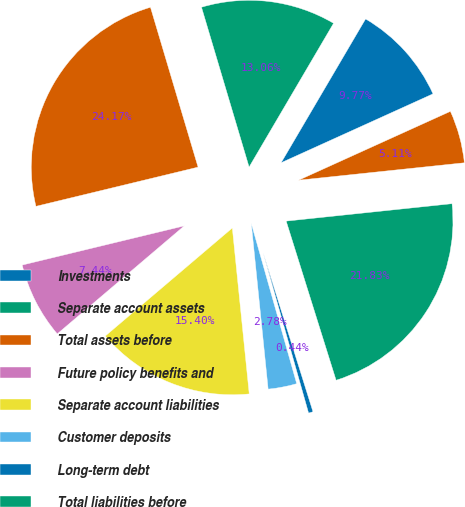Convert chart to OTSL. <chart><loc_0><loc_0><loc_500><loc_500><pie_chart><fcel>Investments<fcel>Separate account assets<fcel>Total assets before<fcel>Future policy benefits and<fcel>Separate account liabilities<fcel>Customer deposits<fcel>Long-term debt<fcel>Total liabilities before<fcel>Total Ameriprise Financial Inc<nl><fcel>9.77%<fcel>13.06%<fcel>24.17%<fcel>7.44%<fcel>15.4%<fcel>2.78%<fcel>0.44%<fcel>21.83%<fcel>5.11%<nl></chart> 